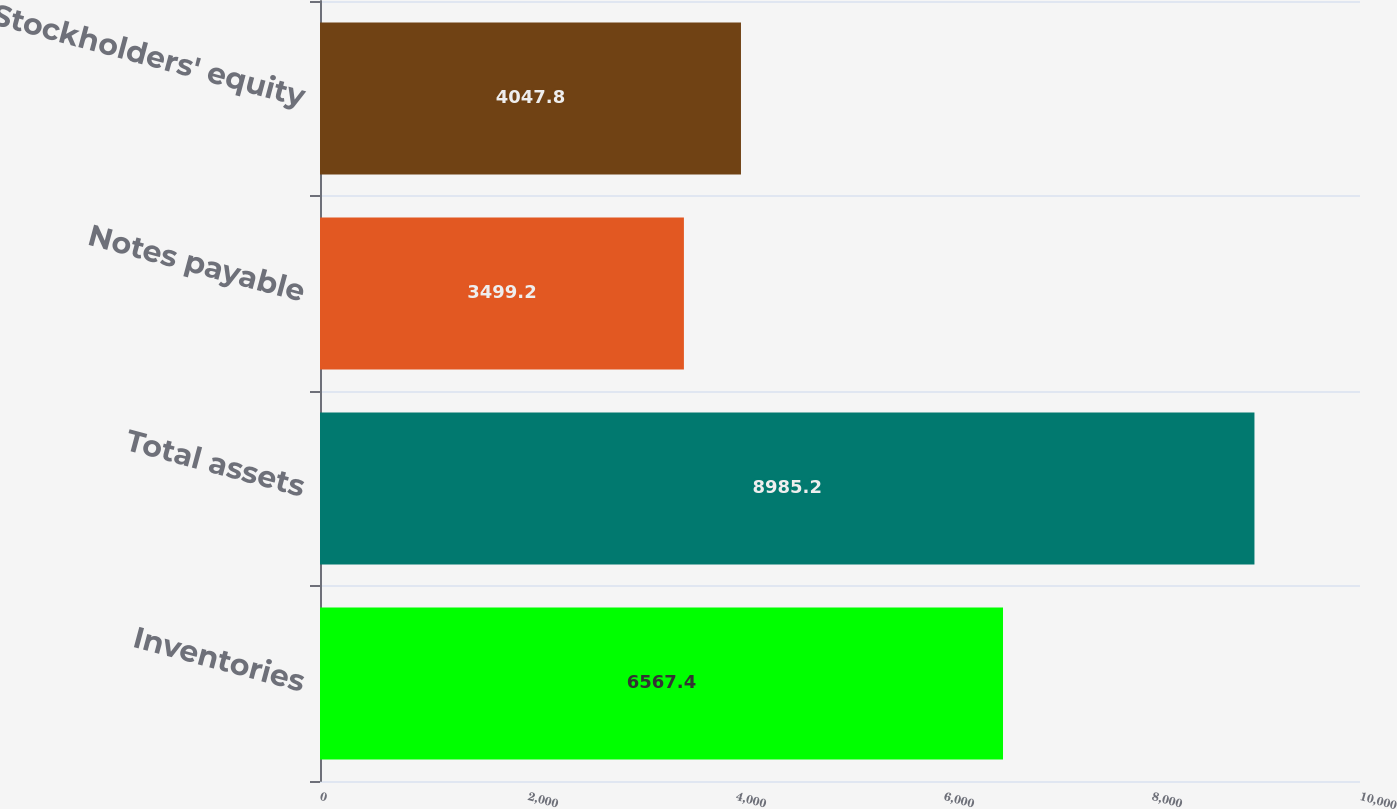Convert chart. <chart><loc_0><loc_0><loc_500><loc_500><bar_chart><fcel>Inventories<fcel>Total assets<fcel>Notes payable<fcel>Stockholders' equity<nl><fcel>6567.4<fcel>8985.2<fcel>3499.2<fcel>4047.8<nl></chart> 